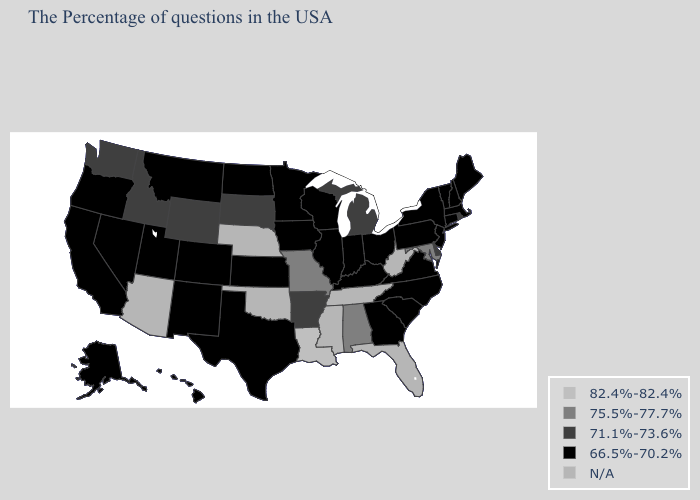What is the value of Georgia?
Short answer required. 66.5%-70.2%. Does Georgia have the highest value in the South?
Write a very short answer. No. What is the value of Louisiana?
Short answer required. 82.4%-82.4%. What is the value of Hawaii?
Keep it brief. 66.5%-70.2%. What is the lowest value in states that border Louisiana?
Concise answer only. 66.5%-70.2%. What is the value of Vermont?
Be succinct. 66.5%-70.2%. What is the lowest value in the USA?
Concise answer only. 66.5%-70.2%. Name the states that have a value in the range 82.4%-82.4%?
Keep it brief. Louisiana. What is the value of California?
Concise answer only. 66.5%-70.2%. Is the legend a continuous bar?
Give a very brief answer. No. Does the first symbol in the legend represent the smallest category?
Quick response, please. No. Which states have the lowest value in the Northeast?
Keep it brief. Maine, Massachusetts, New Hampshire, Vermont, Connecticut, New York, New Jersey, Pennsylvania. Name the states that have a value in the range 71.1%-73.6%?
Quick response, please. Rhode Island, Delaware, Michigan, Arkansas, South Dakota, Wyoming, Idaho, Washington. Does South Carolina have the lowest value in the South?
Be succinct. Yes. How many symbols are there in the legend?
Quick response, please. 5. 